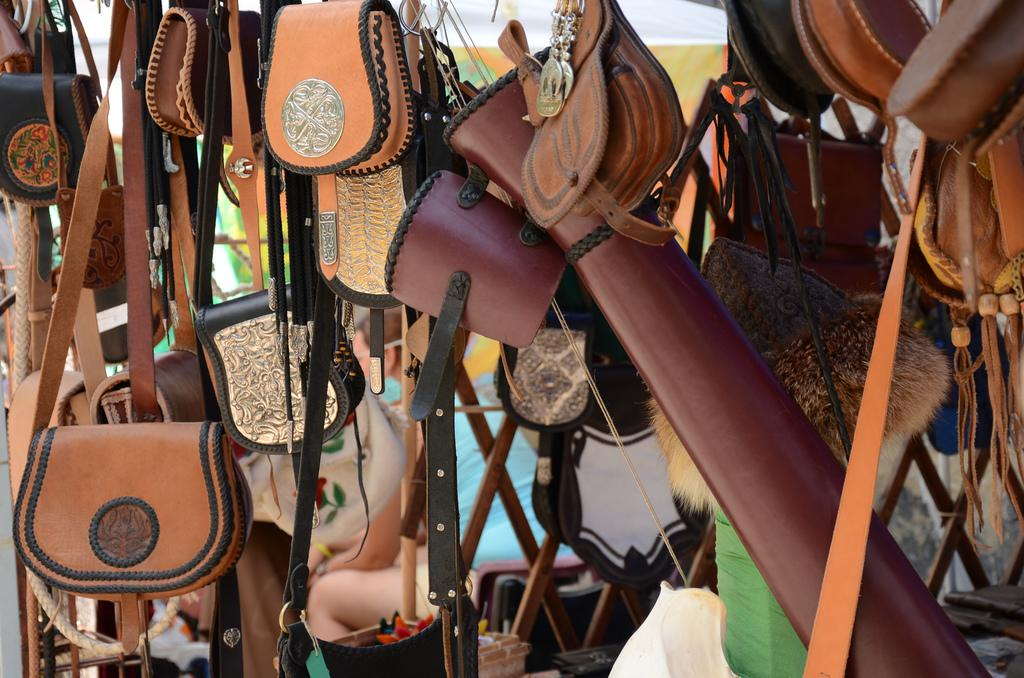What objects are present in the image? There are bags in the image. Can you describe the colors of the bags? The bags are in brown, black, and cream colors. What else can be seen in the image besides the bags? There are people in the background of the image and a banner visible. What type of secretary can be seen working in the image? There is no secretary present in the image. What sound does the thunder make in the image? There is no thunder present in the image. 